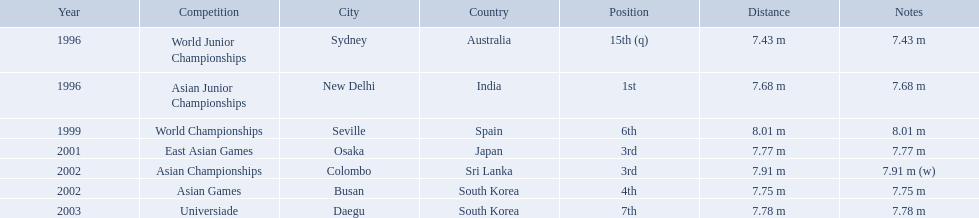What rankings has this competitor placed through the competitions? 15th (q), 1st, 6th, 3rd, 3rd, 4th, 7th. In which competition did the competitor place 1st? Asian Junior Championships. What are the competitions that huang le participated in? World Junior Championships, Asian Junior Championships, World Championships, East Asian Games, Asian Championships, Asian Games, Universiade. Which competitions did he participate in 2002 Asian Championships, Asian Games. What are the lengths of his jumps that year? 7.91 m (w), 7.75 m. What is the longest length of a jump? 7.91 m (w). 